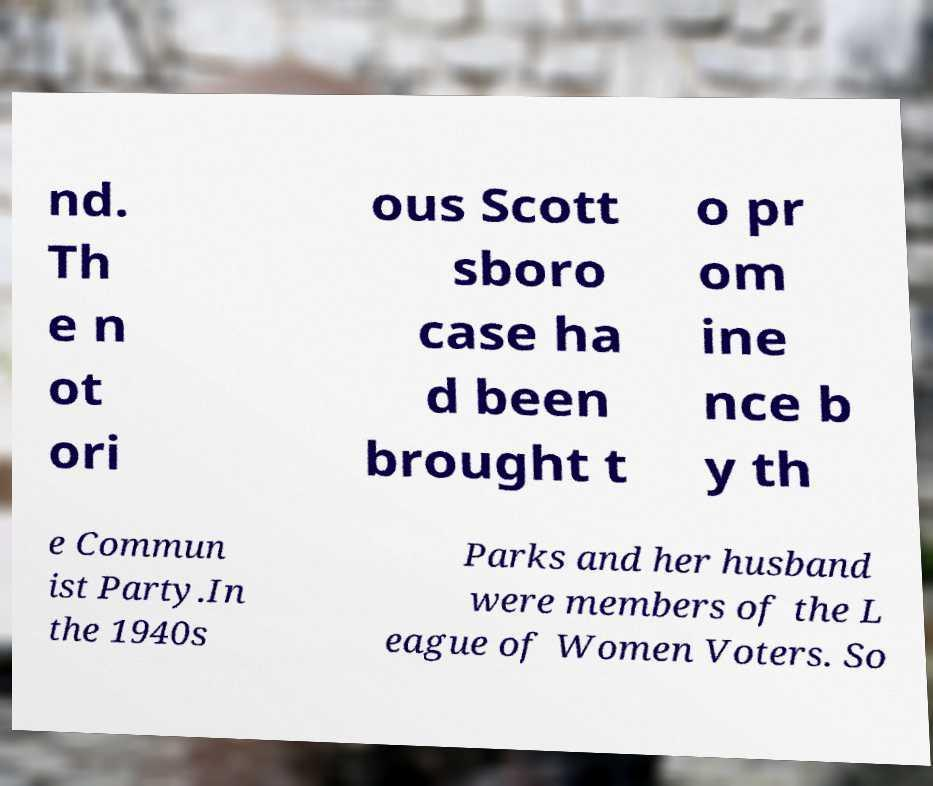Can you accurately transcribe the text from the provided image for me? nd. Th e n ot ori ous Scott sboro case ha d been brought t o pr om ine nce b y th e Commun ist Party.In the 1940s Parks and her husband were members of the L eague of Women Voters. So 